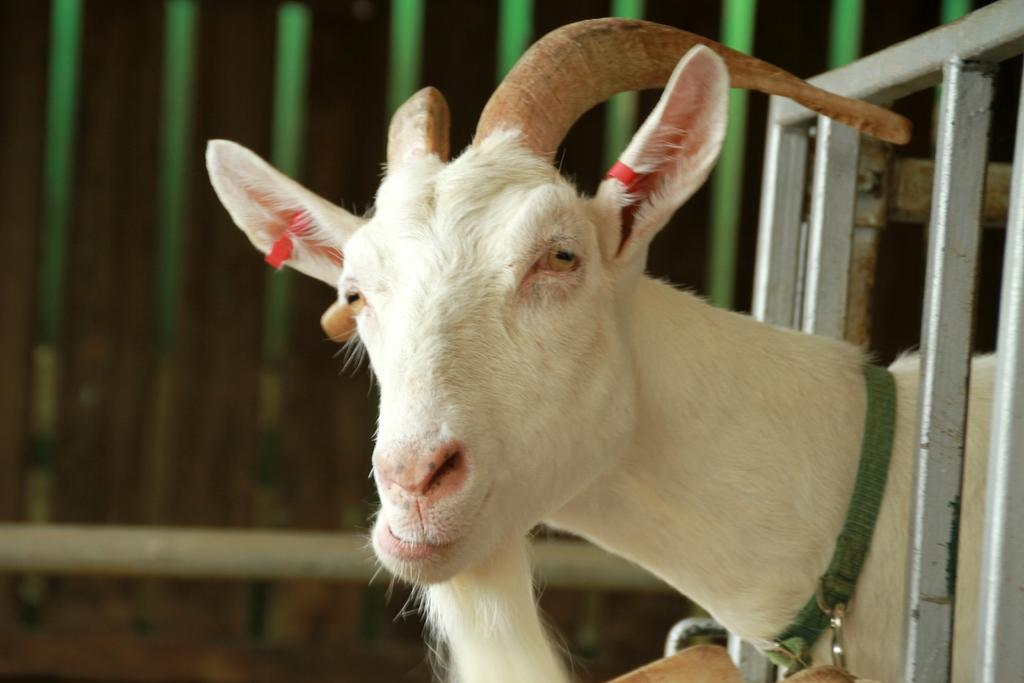What type of animal is present in the image? There is an animal in the image, but its specific type cannot be determined from the provided facts. What else can be seen in the image besides the animal? There are rods in the image. What is the animal's reaction to the sneeze in the image? There is no sneeze present in the image, so the animal's reaction cannot be determined. What type of dinner is being prepared in the image? There is no reference to dinner or any food preparation in the image, so it cannot be determined. 